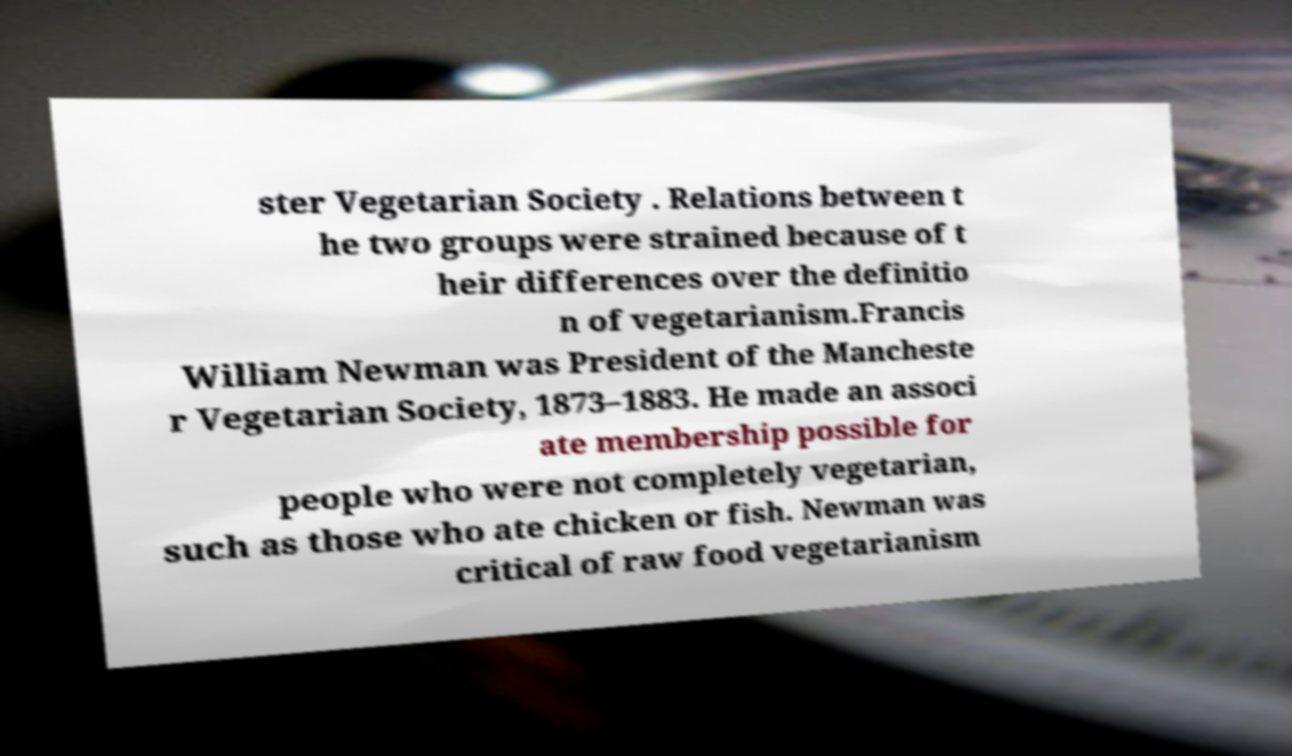Can you read and provide the text displayed in the image?This photo seems to have some interesting text. Can you extract and type it out for me? ster Vegetarian Society . Relations between t he two groups were strained because of t heir differences over the definitio n of vegetarianism.Francis William Newman was President of the Mancheste r Vegetarian Society, 1873–1883. He made an associ ate membership possible for people who were not completely vegetarian, such as those who ate chicken or fish. Newman was critical of raw food vegetarianism 